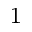Convert formula to latex. <formula><loc_0><loc_0><loc_500><loc_500>^ { 1 }</formula> 